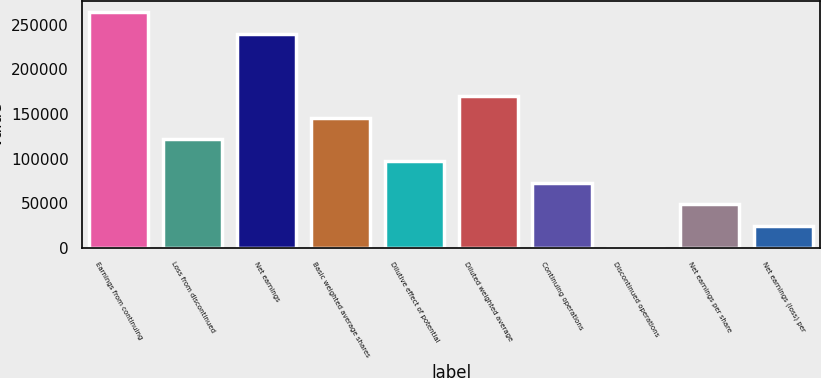Convert chart. <chart><loc_0><loc_0><loc_500><loc_500><bar_chart><fcel>Earnings from continuing<fcel>Loss from discontinued<fcel>Net earnings<fcel>Basic weighted average shares<fcel>Dilutive effect of potential<fcel>Diluted weighted average<fcel>Continuing operations<fcel>Discontinued operations<fcel>Net earnings per share<fcel>Net earnings (loss) per<nl><fcel>263748<fcel>121458<fcel>239456<fcel>145750<fcel>97166.4<fcel>170041<fcel>72874.8<fcel>0.03<fcel>48583.2<fcel>24291.6<nl></chart> 